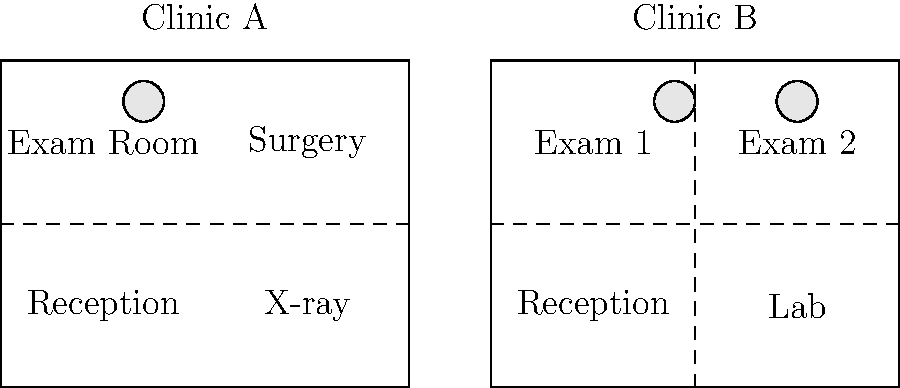Based on the floor plans of two veterinary clinics shown above, which clinic is better equipped to handle a wider variety of animal species, including both small pets and larger animals? To determine which clinic is better equipped to handle a wider variety of animal species, we need to analyze the layout and facilities of both clinics:

1. Clinic A:
   - Has a dedicated surgery room, which is crucial for both small and large animals
   - Features an X-ray room, essential for diagnosing issues in various animal sizes
   - Has one exam room, which might be limiting for different species
   - The layout suggests a more specialized setup

2. Clinic B:
   - Has two exam rooms, allowing for greater flexibility in accommodating different animal sizes
   - Features a laboratory, which is important for on-site testing and diagnostics
   - Lacks a dedicated surgery room, which could be a limitation for more complex procedures
   - The layout suggests a more general-purpose setup

3. Comparing the two:
   - Clinic A has specialized equipment (surgery and X-ray) that can handle more complex cases for various animal sizes
   - Clinic B has more exam space, allowing for better accommodation of different species simultaneously
   - Clinic A's surgery room gives it an edge in handling emergencies and complex procedures for both small and large animals

4. Conclusion:
   While both clinics have their strengths, Clinic A appears better equipped to handle a wider variety of animal species due to its specialized rooms (surgery and X-ray) that can accommodate both small pets and larger animals. The surgery room, in particular, is a critical facility for treating various species and handling emergencies.
Answer: Clinic A 